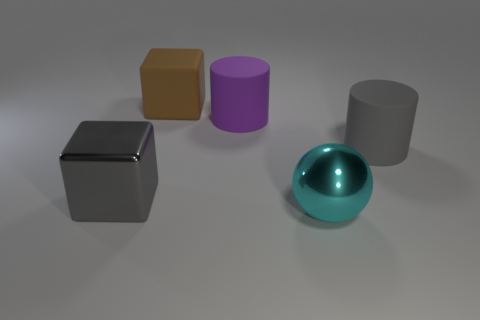Add 2 blue rubber cylinders. How many objects exist? 7 Subtract all cubes. How many objects are left? 3 Subtract all blocks. Subtract all big brown things. How many objects are left? 2 Add 4 gray rubber objects. How many gray rubber objects are left? 5 Add 1 purple matte objects. How many purple matte objects exist? 2 Subtract 0 green spheres. How many objects are left? 5 